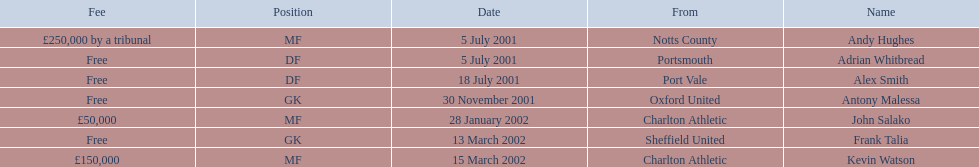List all the players names Andy Hughes, Adrian Whitbread, Alex Smith, Antony Malessa, John Salako, Frank Talia, Kevin Watson. Of these who is kevin watson Kevin Watson. To what transfer fee entry does kevin correspond to? £150,000. 